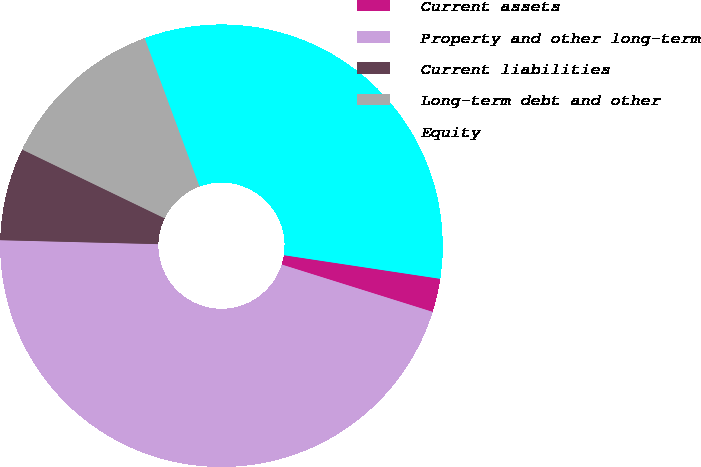Convert chart. <chart><loc_0><loc_0><loc_500><loc_500><pie_chart><fcel>Current assets<fcel>Property and other long-term<fcel>Current liabilities<fcel>Long-term debt and other<fcel>Equity<nl><fcel>2.45%<fcel>45.56%<fcel>6.76%<fcel>12.21%<fcel>33.02%<nl></chart> 